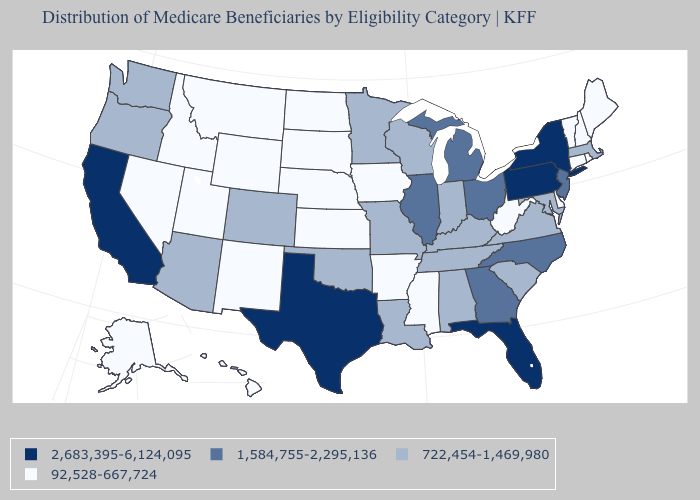Name the states that have a value in the range 92,528-667,724?
Concise answer only. Alaska, Arkansas, Connecticut, Delaware, Hawaii, Idaho, Iowa, Kansas, Maine, Mississippi, Montana, Nebraska, Nevada, New Hampshire, New Mexico, North Dakota, Rhode Island, South Dakota, Utah, Vermont, West Virginia, Wyoming. Among the states that border West Virginia , does Ohio have the lowest value?
Keep it brief. No. What is the value of Maine?
Quick response, please. 92,528-667,724. Does Washington have the same value as Maryland?
Quick response, please. Yes. Does Missouri have the lowest value in the MidWest?
Be succinct. No. Name the states that have a value in the range 1,584,755-2,295,136?
Short answer required. Georgia, Illinois, Michigan, New Jersey, North Carolina, Ohio. Name the states that have a value in the range 2,683,395-6,124,095?
Short answer required. California, Florida, New York, Pennsylvania, Texas. What is the value of Washington?
Answer briefly. 722,454-1,469,980. Does Alaska have the highest value in the USA?
Keep it brief. No. Is the legend a continuous bar?
Keep it brief. No. Does the first symbol in the legend represent the smallest category?
Answer briefly. No. Name the states that have a value in the range 2,683,395-6,124,095?
Write a very short answer. California, Florida, New York, Pennsylvania, Texas. Does the map have missing data?
Be succinct. No. Does Mississippi have a lower value than Wyoming?
Answer briefly. No. Does Ohio have a higher value than Maine?
Be succinct. Yes. 